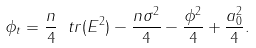Convert formula to latex. <formula><loc_0><loc_0><loc_500><loc_500>\phi _ { t } = \frac { n } { 4 } \ t r ( E ^ { 2 } ) - \frac { n \sigma ^ { 2 } } 4 - \frac { \phi ^ { 2 } } 4 + \frac { a _ { 0 } ^ { 2 } } 4 .</formula> 